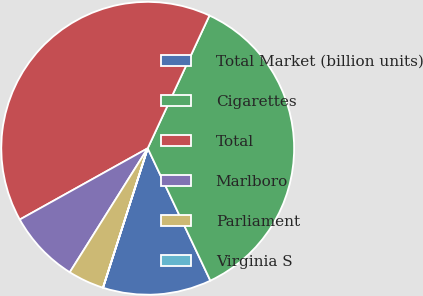<chart> <loc_0><loc_0><loc_500><loc_500><pie_chart><fcel>Total Market (billion units)<fcel>Cigarettes<fcel>Total<fcel>Marlboro<fcel>Parliament<fcel>Virginia S<nl><fcel>11.97%<fcel>36.04%<fcel>40.02%<fcel>7.98%<fcel>3.99%<fcel>0.01%<nl></chart> 